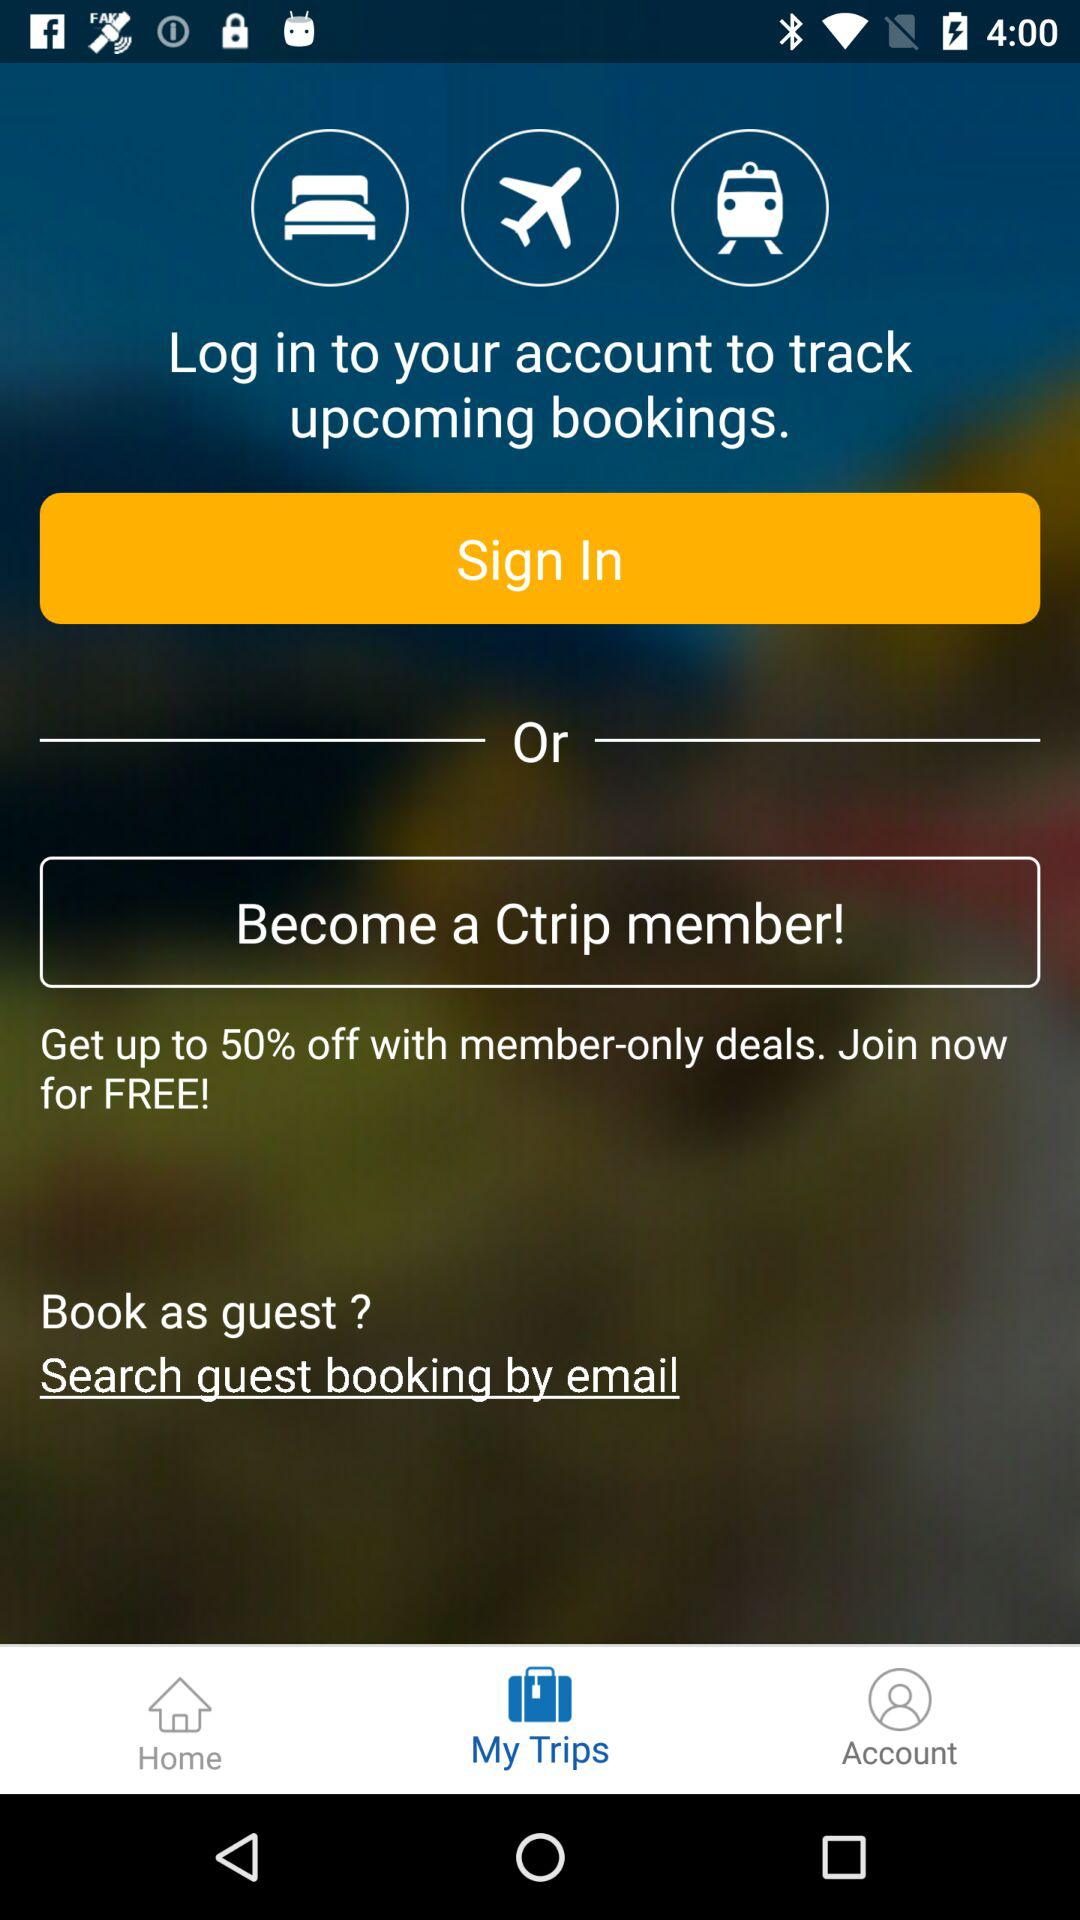How much of a discount is available? A discount of up to 50% is available. 